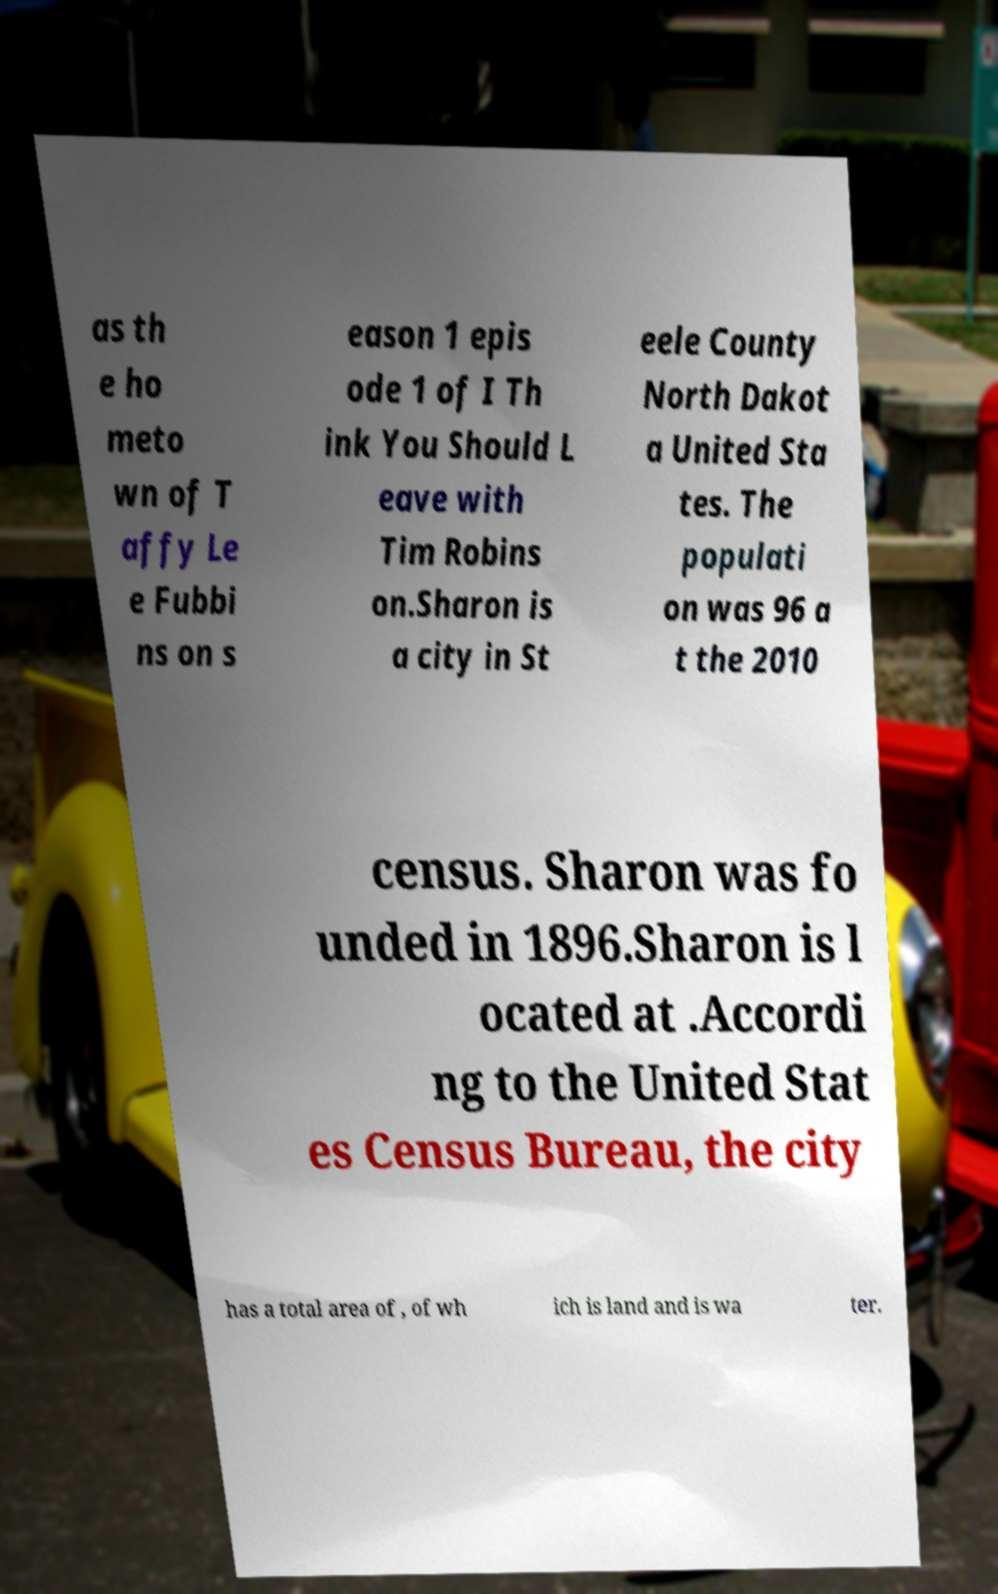There's text embedded in this image that I need extracted. Can you transcribe it verbatim? as th e ho meto wn of T affy Le e Fubbi ns on s eason 1 epis ode 1 of I Th ink You Should L eave with Tim Robins on.Sharon is a city in St eele County North Dakot a United Sta tes. The populati on was 96 a t the 2010 census. Sharon was fo unded in 1896.Sharon is l ocated at .Accordi ng to the United Stat es Census Bureau, the city has a total area of , of wh ich is land and is wa ter. 